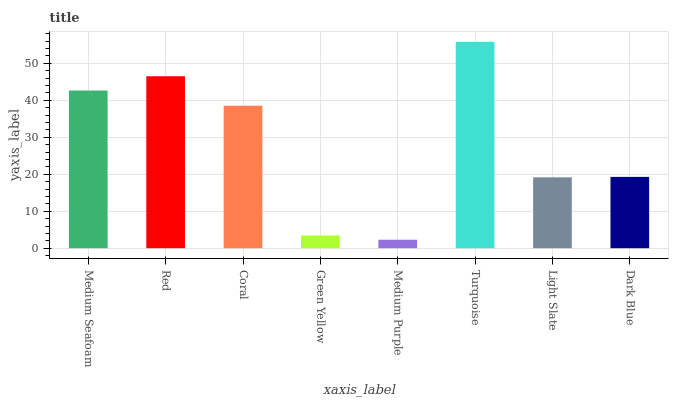Is Red the minimum?
Answer yes or no. No. Is Red the maximum?
Answer yes or no. No. Is Red greater than Medium Seafoam?
Answer yes or no. Yes. Is Medium Seafoam less than Red?
Answer yes or no. Yes. Is Medium Seafoam greater than Red?
Answer yes or no. No. Is Red less than Medium Seafoam?
Answer yes or no. No. Is Coral the high median?
Answer yes or no. Yes. Is Dark Blue the low median?
Answer yes or no. Yes. Is Medium Seafoam the high median?
Answer yes or no. No. Is Green Yellow the low median?
Answer yes or no. No. 